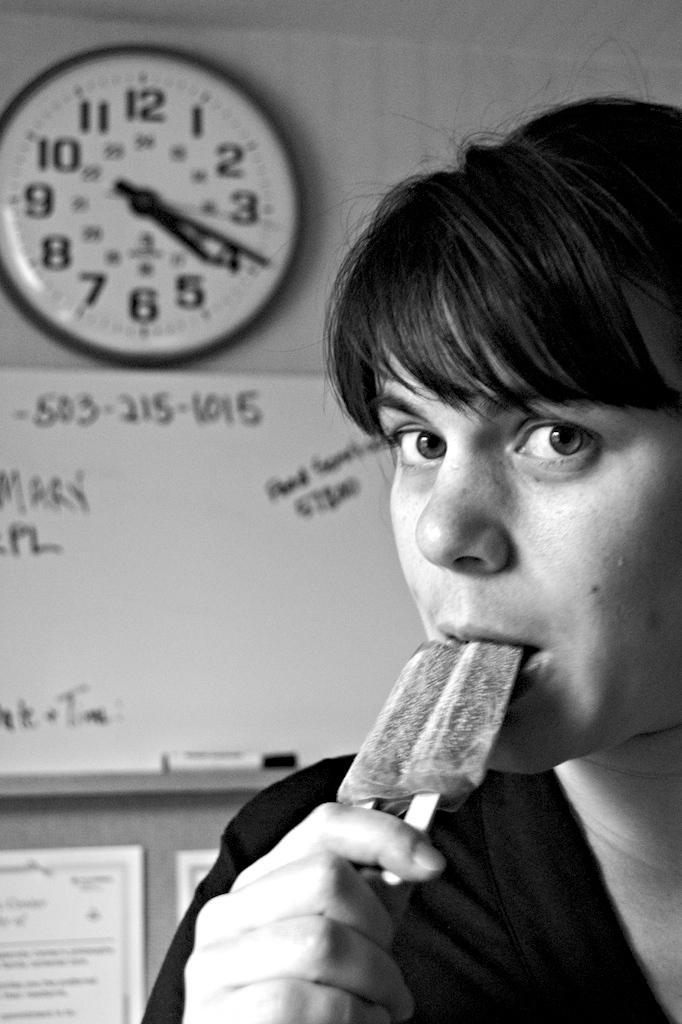Who is the main subject in the image? There is a woman in the image. What is the woman doing in the image? The woman is eating ice cream. What can be seen in the background of the image? There is a whiteboard, a marker, a clock, and papers pasted on the wall in the background of the image. How does the woman adjust the competition in the image? There is no competition present in the image, so it is not possible to discuss any adjustments related to it. 